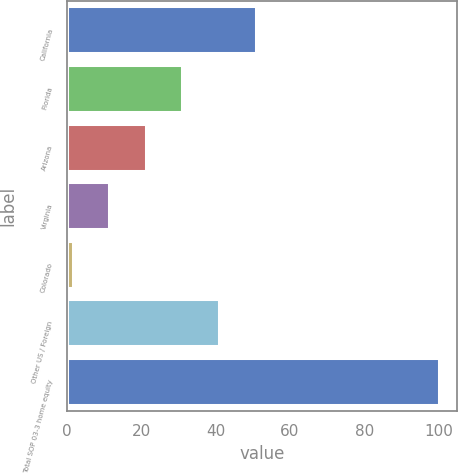Convert chart to OTSL. <chart><loc_0><loc_0><loc_500><loc_500><bar_chart><fcel>California<fcel>Florida<fcel>Arizona<fcel>Virginia<fcel>Colorado<fcel>Other US / Foreign<fcel>Total SOP 03-3 home equity<nl><fcel>50.75<fcel>31.05<fcel>21.2<fcel>11.35<fcel>1.5<fcel>40.9<fcel>100<nl></chart> 